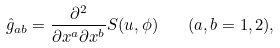Convert formula to latex. <formula><loc_0><loc_0><loc_500><loc_500>\hat { g } _ { a b } = \frac { \partial ^ { 2 } } { \partial x ^ { a } \partial x ^ { b } } S ( u , \phi ) \quad ( a , b = 1 , 2 ) ,</formula> 